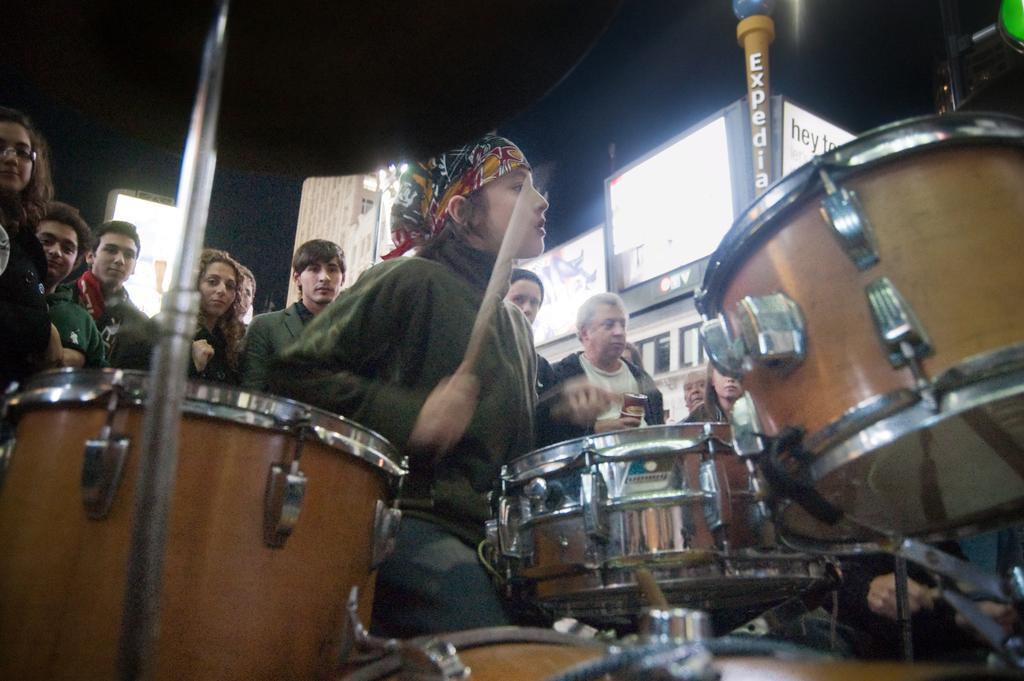How would you summarize this image in a sentence or two? In this image there are musical instruments in the front and there is a person holding a stick and in the background there are persons standing and there are buildings and there are boards with some text written on it. 